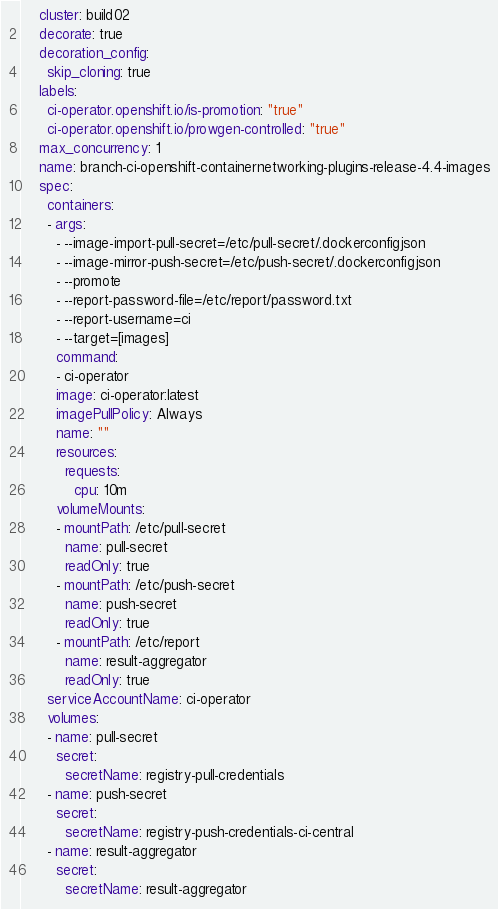<code> <loc_0><loc_0><loc_500><loc_500><_YAML_>    cluster: build02
    decorate: true
    decoration_config:
      skip_cloning: true
    labels:
      ci-operator.openshift.io/is-promotion: "true"
      ci-operator.openshift.io/prowgen-controlled: "true"
    max_concurrency: 1
    name: branch-ci-openshift-containernetworking-plugins-release-4.4-images
    spec:
      containers:
      - args:
        - --image-import-pull-secret=/etc/pull-secret/.dockerconfigjson
        - --image-mirror-push-secret=/etc/push-secret/.dockerconfigjson
        - --promote
        - --report-password-file=/etc/report/password.txt
        - --report-username=ci
        - --target=[images]
        command:
        - ci-operator
        image: ci-operator:latest
        imagePullPolicy: Always
        name: ""
        resources:
          requests:
            cpu: 10m
        volumeMounts:
        - mountPath: /etc/pull-secret
          name: pull-secret
          readOnly: true
        - mountPath: /etc/push-secret
          name: push-secret
          readOnly: true
        - mountPath: /etc/report
          name: result-aggregator
          readOnly: true
      serviceAccountName: ci-operator
      volumes:
      - name: pull-secret
        secret:
          secretName: registry-pull-credentials
      - name: push-secret
        secret:
          secretName: registry-push-credentials-ci-central
      - name: result-aggregator
        secret:
          secretName: result-aggregator
</code> 